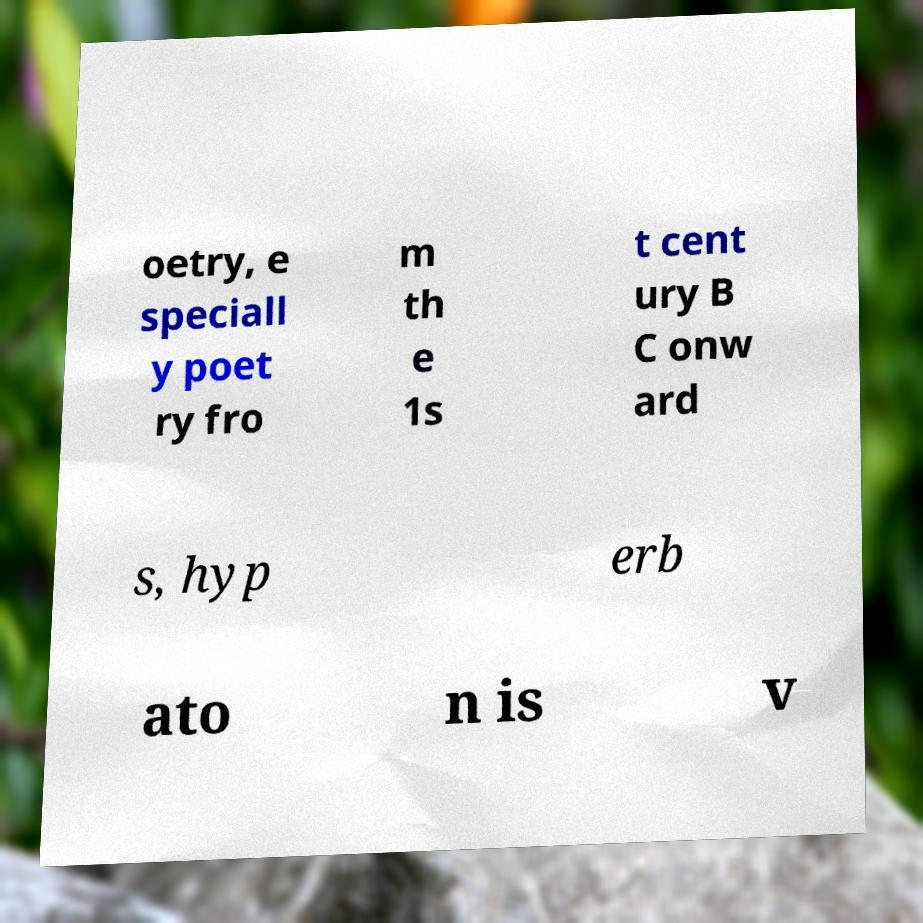I need the written content from this picture converted into text. Can you do that? oetry, e speciall y poet ry fro m th e 1s t cent ury B C onw ard s, hyp erb ato n is v 